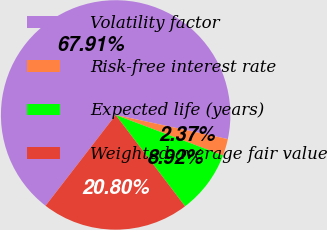Convert chart. <chart><loc_0><loc_0><loc_500><loc_500><pie_chart><fcel>Volatility factor<fcel>Risk-free interest rate<fcel>Expected life (years)<fcel>Weighted-average fair value<nl><fcel>67.91%<fcel>2.37%<fcel>8.92%<fcel>20.8%<nl></chart> 